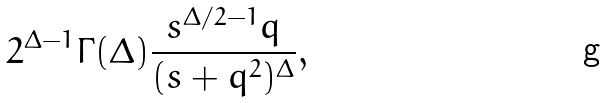Convert formula to latex. <formula><loc_0><loc_0><loc_500><loc_500>2 ^ { \Delta - 1 } \Gamma ( \Delta ) \frac { s ^ { \Delta / 2 - 1 } q } { ( s + q ^ { 2 } ) ^ { \Delta } } ,</formula> 